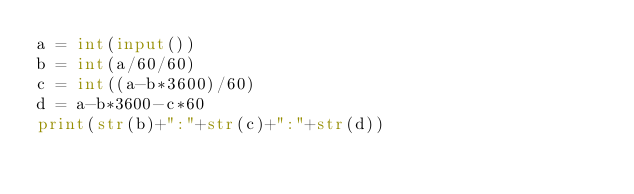<code> <loc_0><loc_0><loc_500><loc_500><_Python_>a = int(input())
b = int(a/60/60)
c = int((a-b*3600)/60)
d = a-b*3600-c*60
print(str(b)+":"+str(c)+":"+str(d))
</code> 